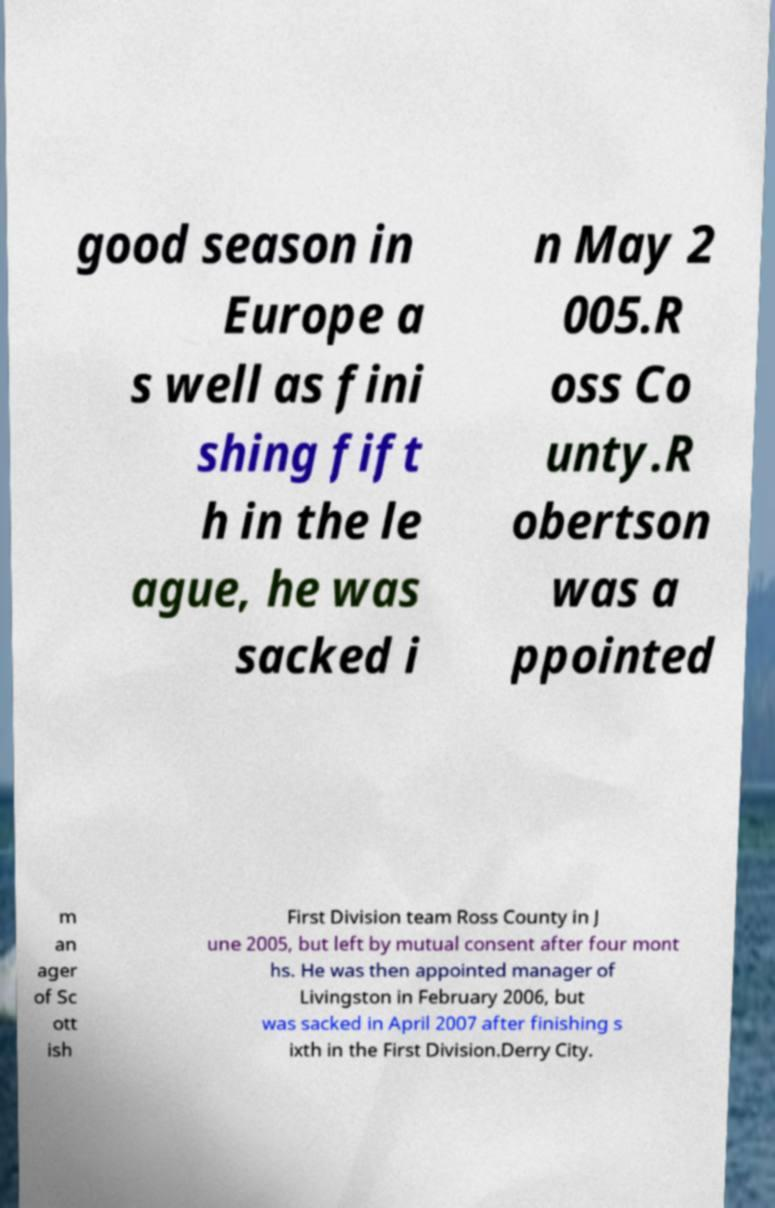Could you extract and type out the text from this image? good season in Europe a s well as fini shing fift h in the le ague, he was sacked i n May 2 005.R oss Co unty.R obertson was a ppointed m an ager of Sc ott ish First Division team Ross County in J une 2005, but left by mutual consent after four mont hs. He was then appointed manager of Livingston in February 2006, but was sacked in April 2007 after finishing s ixth in the First Division.Derry City. 